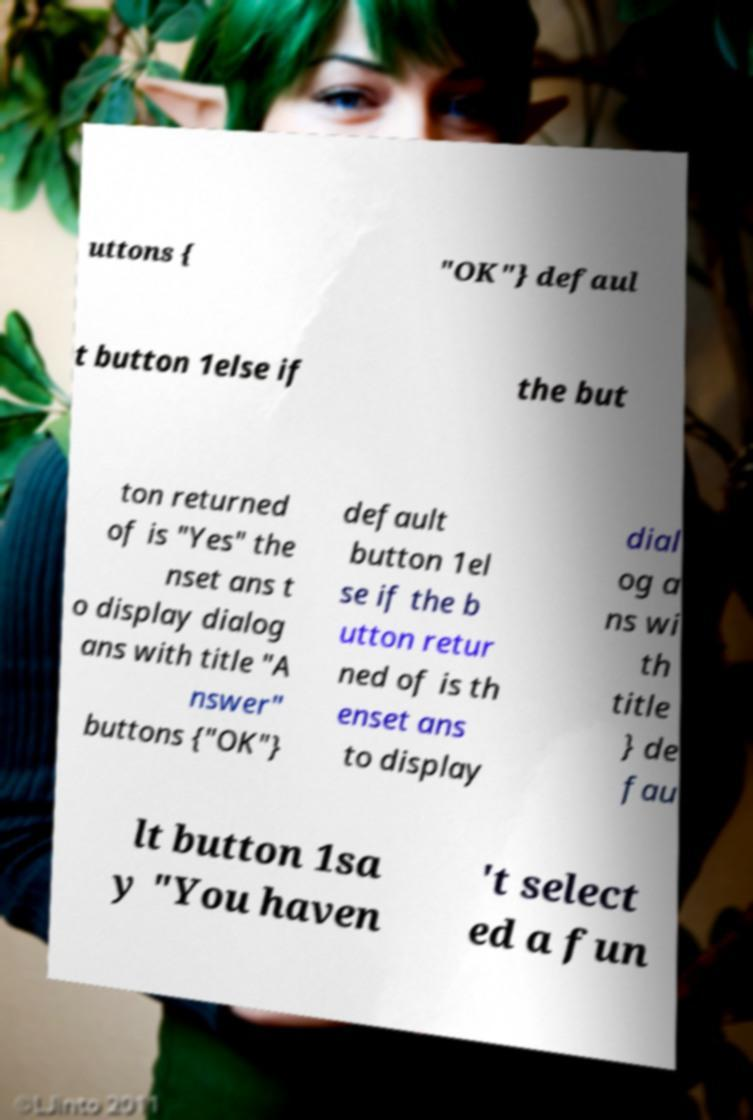Please read and relay the text visible in this image. What does it say? uttons { "OK"} defaul t button 1else if the but ton returned of is "Yes" the nset ans t o display dialog ans with title "A nswer" buttons {"OK"} default button 1el se if the b utton retur ned of is th enset ans to display dial og a ns wi th title } de fau lt button 1sa y "You haven 't select ed a fun 